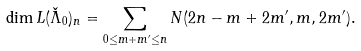Convert formula to latex. <formula><loc_0><loc_0><loc_500><loc_500>\dim L ( \check { \Lambda } _ { 0 } ) _ { n } = \sum _ { 0 \leq m + m ^ { \prime } \leq n } N ( 2 n - m + 2 m ^ { \prime } , m , 2 m ^ { \prime } ) .</formula> 